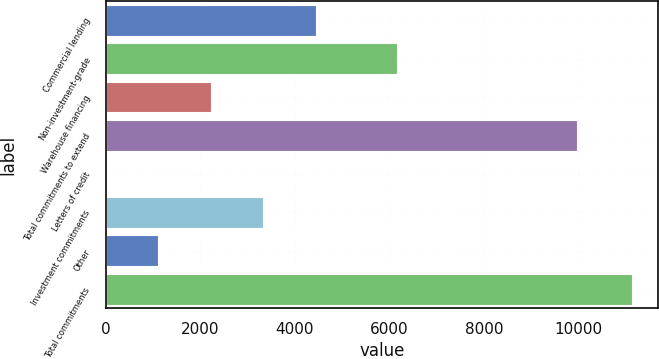Convert chart. <chart><loc_0><loc_0><loc_500><loc_500><bar_chart><fcel>Commercial lending<fcel>Non-investment-grade<fcel>Warehouse financing<fcel>Total commitments to extend<fcel>Letters of credit<fcel>Investment commitments<fcel>Other<fcel>Total commitments<nl><fcel>4452.4<fcel>6172<fcel>2228.2<fcel>9976<fcel>4<fcel>3340.3<fcel>1116.1<fcel>11125<nl></chart> 